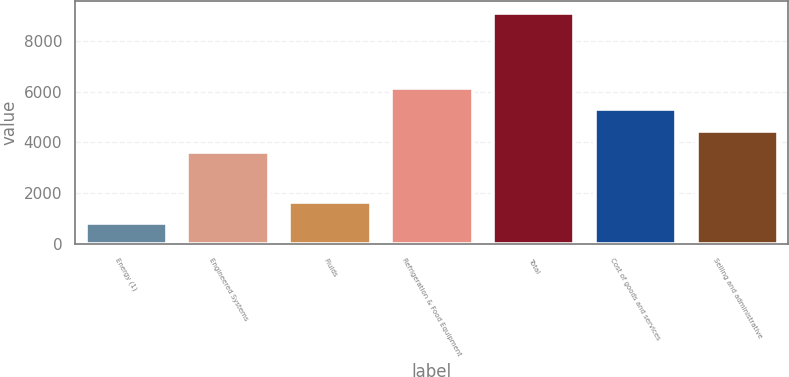Convert chart. <chart><loc_0><loc_0><loc_500><loc_500><bar_chart><fcel>Energy (1)<fcel>Engineered Systems<fcel>Fluids<fcel>Refrigeration & Food Equipment<fcel>Total<fcel>Cost of goods and services<fcel>Selling and administrative<nl><fcel>811<fcel>3628<fcel>1641.7<fcel>6150.7<fcel>9118<fcel>5320<fcel>4458.7<nl></chart> 